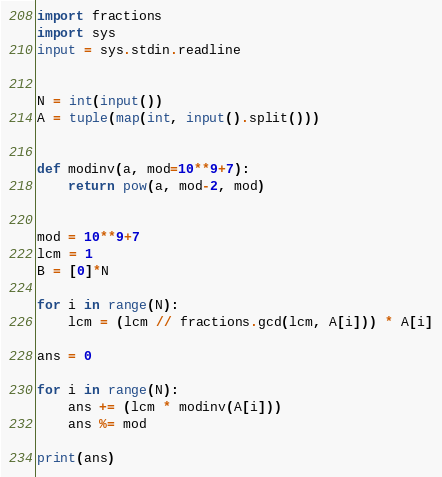<code> <loc_0><loc_0><loc_500><loc_500><_Python_>import fractions
import sys
input = sys.stdin.readline


N = int(input())
A = tuple(map(int, input().split()))


def modinv(a, mod=10**9+7):
    return pow(a, mod-2, mod)


mod = 10**9+7
lcm = 1
B = [0]*N

for i in range(N):
    lcm = (lcm // fractions.gcd(lcm, A[i])) * A[i]

ans = 0

for i in range(N):
    ans += (lcm * modinv(A[i]))
    ans %= mod

print(ans)
</code> 